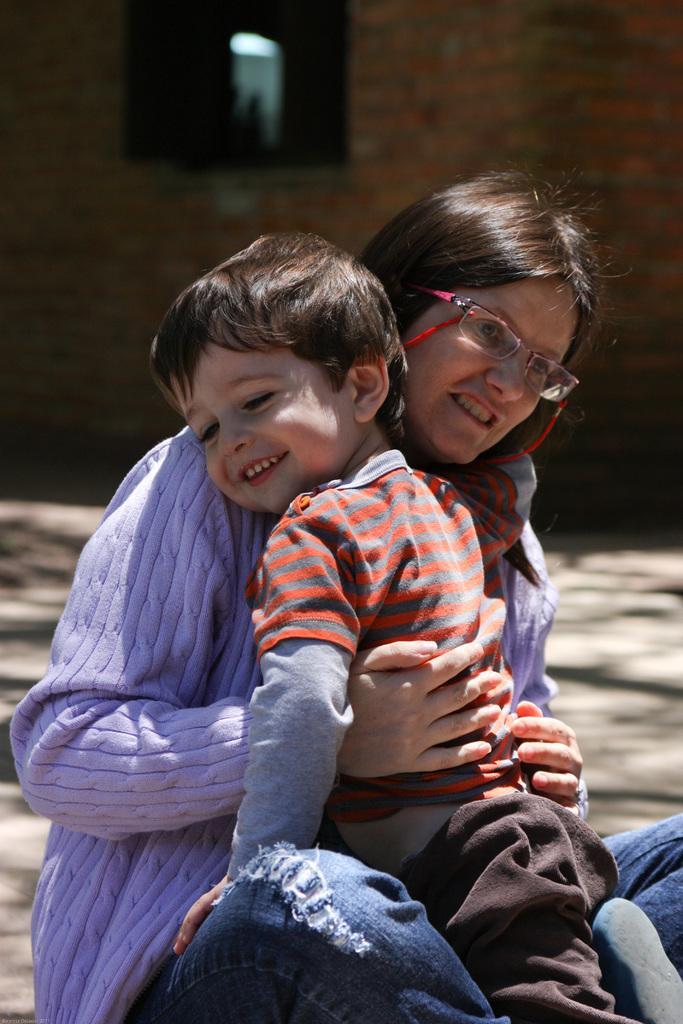How would you summarize this image in a sentence or two? In this picture I can see there is a woman sitting and she is wearing a purple sweater and she is hugging a boy and she is having spectacles and looking at right side and the boy is smiling and looking at left side. In the backdrop there is a building and it has a window. The backdrop is blurred. 